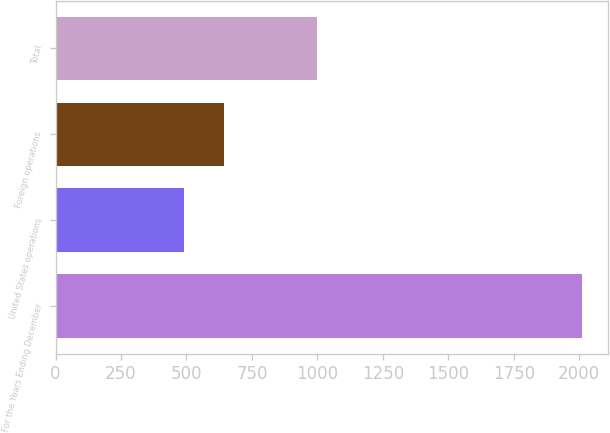Convert chart to OTSL. <chart><loc_0><loc_0><loc_500><loc_500><bar_chart><fcel>For the Years Ending December<fcel>United States operations<fcel>Foreign operations<fcel>Total<nl><fcel>2009<fcel>489.7<fcel>641.63<fcel>998.2<nl></chart> 